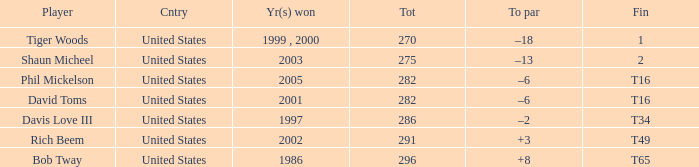What is the to par number of the person who won in 2003? –13. 